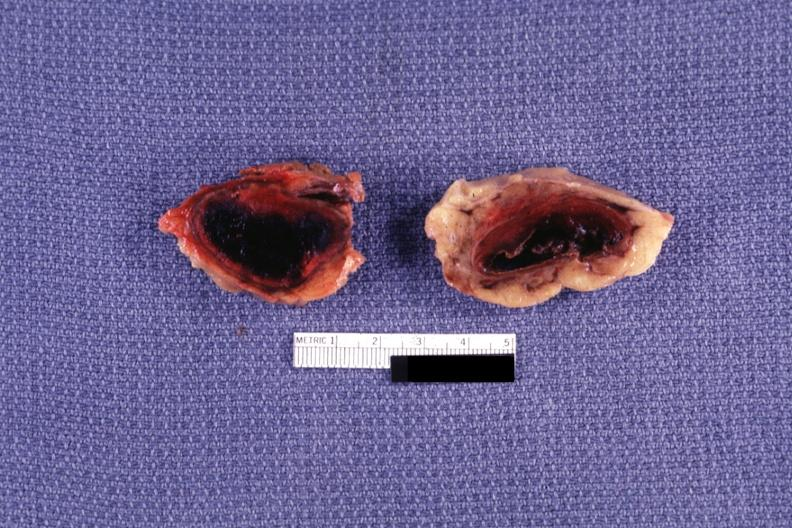what is present?
Answer the question using a single word or phrase. Endocrine 